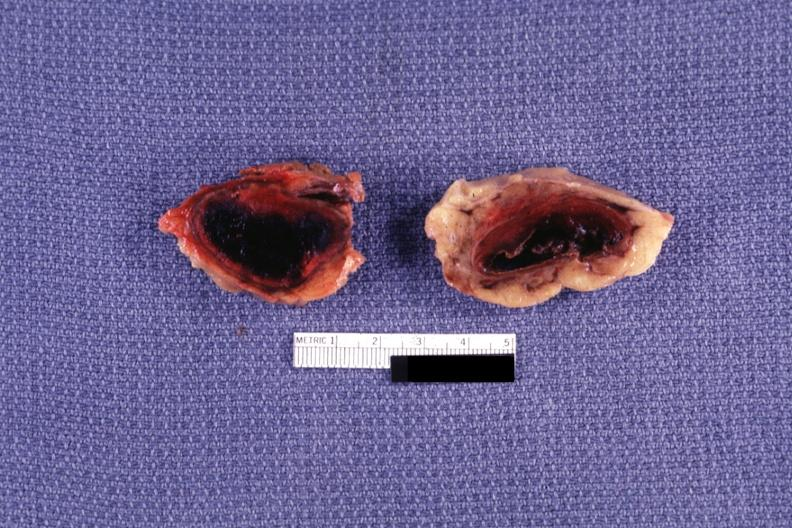what is present?
Answer the question using a single word or phrase. Endocrine 